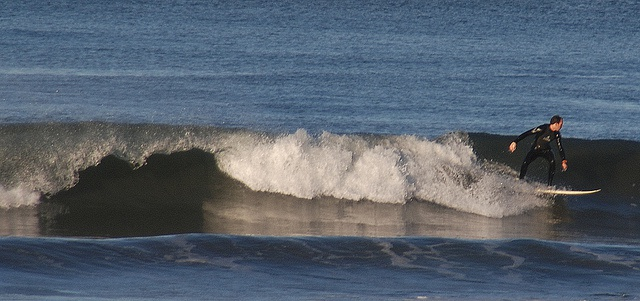Describe the objects in this image and their specific colors. I can see people in gray, black, brown, and salmon tones and surfboard in gray, tan, khaki, black, and beige tones in this image. 